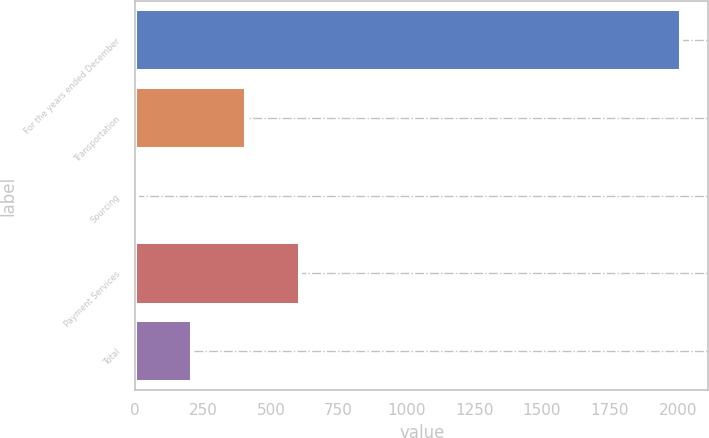Convert chart to OTSL. <chart><loc_0><loc_0><loc_500><loc_500><bar_chart><fcel>For the years ended December<fcel>Transportation<fcel>Sourcing<fcel>Payment Services<fcel>Total<nl><fcel>2013<fcel>408.68<fcel>7.6<fcel>609.22<fcel>208.14<nl></chart> 